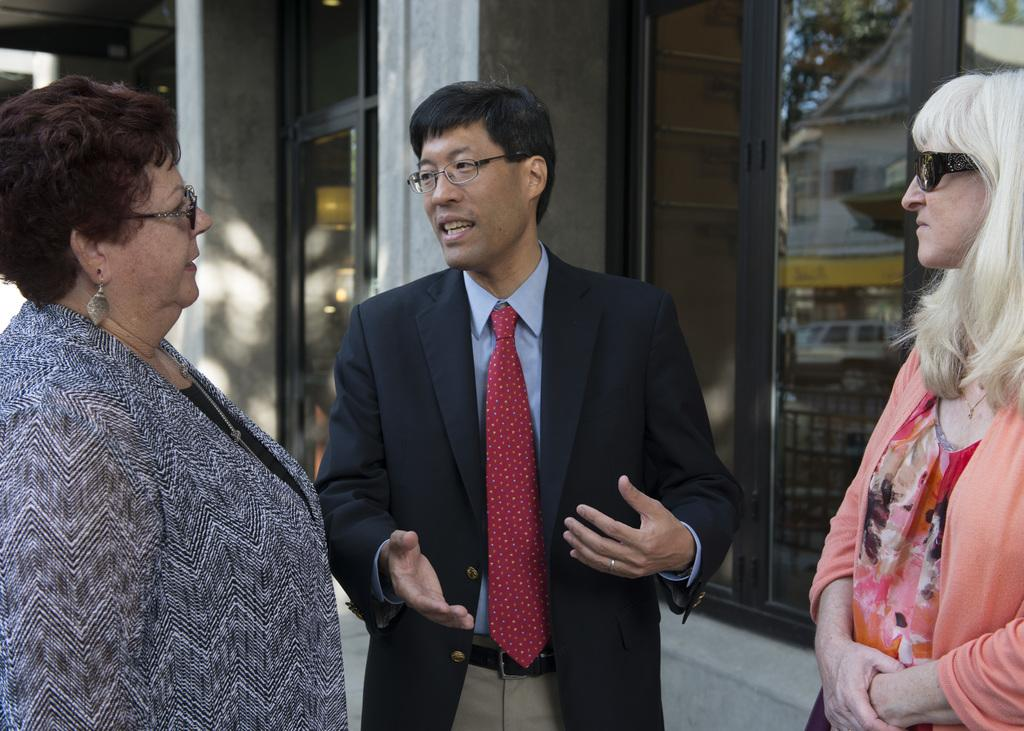Who or what is present in the image? There are people in the image. What are the people wearing? The people are wearing glasses. What are the people doing in the image? The people are standing. What can be seen in the background of the image? There are buildings in the background of the image. How many beggars are visible on the shelf in the image? There are no beggars or shelves present in the image. 